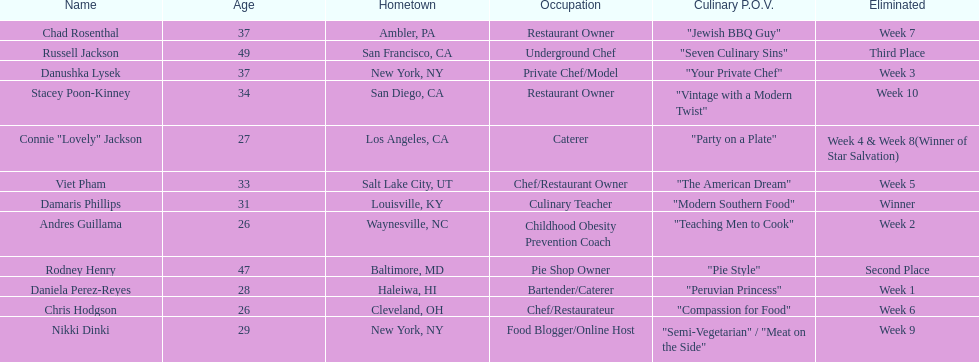How many competitors were under the age of 30? 5. 